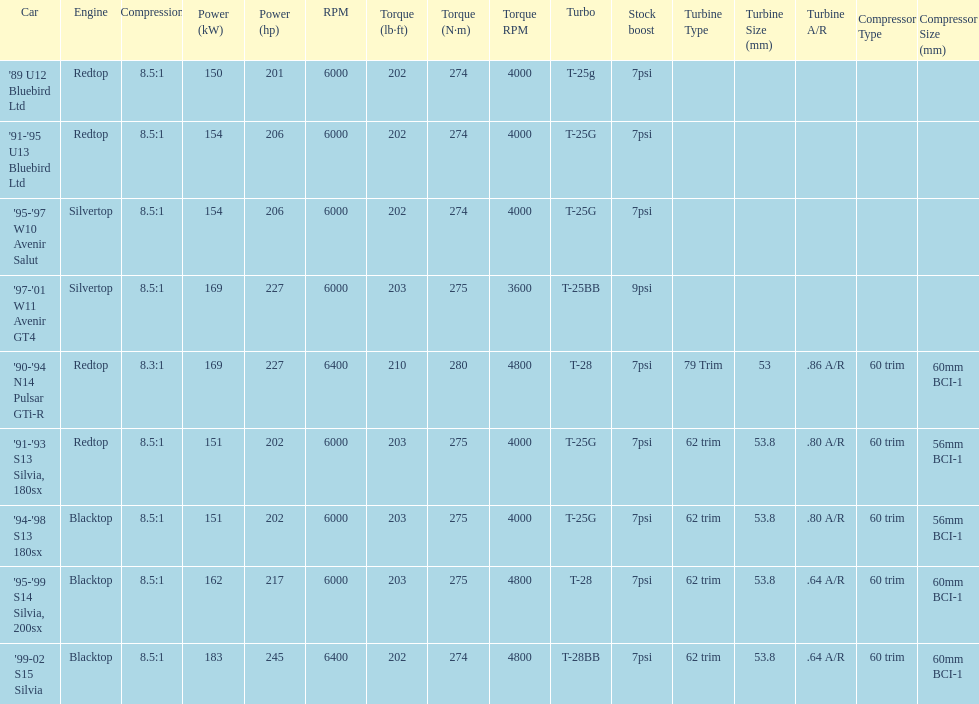Which of the cars uses the redtop engine? '89 U12 Bluebird Ltd, '91-'95 U13 Bluebird Ltd, '90-'94 N14 Pulsar GTi-R, '91-'93 S13 Silvia, 180sx. Of these, has more than 220 horsepower? '90-'94 N14 Pulsar GTi-R. What is the compression ratio of this car? 8.3:1. 